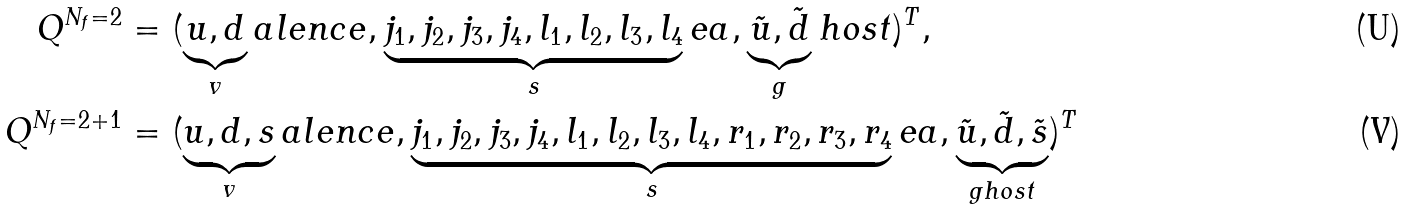Convert formula to latex. <formula><loc_0><loc_0><loc_500><loc_500>Q ^ { N _ { f } = 2 } & = ( \underbrace { u , d } _ { v } a l e n c e , \underbrace { j _ { 1 } , j _ { 2 } , j _ { 3 } , j _ { 4 } , l _ { 1 } , l _ { 2 } , l _ { 3 } , l _ { 4 } } _ { s } e a , \underbrace { \tilde { u } , \tilde { d } } _ { g } h o s t ) ^ { T } , \\ Q ^ { N _ { f } = 2 + 1 } & = ( \underbrace { u , d , s } _ { v } a l e n c e , \underbrace { j _ { 1 } , j _ { 2 } , j _ { 3 } , j _ { 4 } , l _ { 1 } , l _ { 2 } , l _ { 3 } , l _ { 4 } , r _ { 1 } , r _ { 2 } , r _ { 3 } , r _ { 4 } } _ { s } e a , \underbrace { \tilde { u } , \tilde { d } , \tilde { s } } _ { g h o s t } ) ^ { T }</formula> 